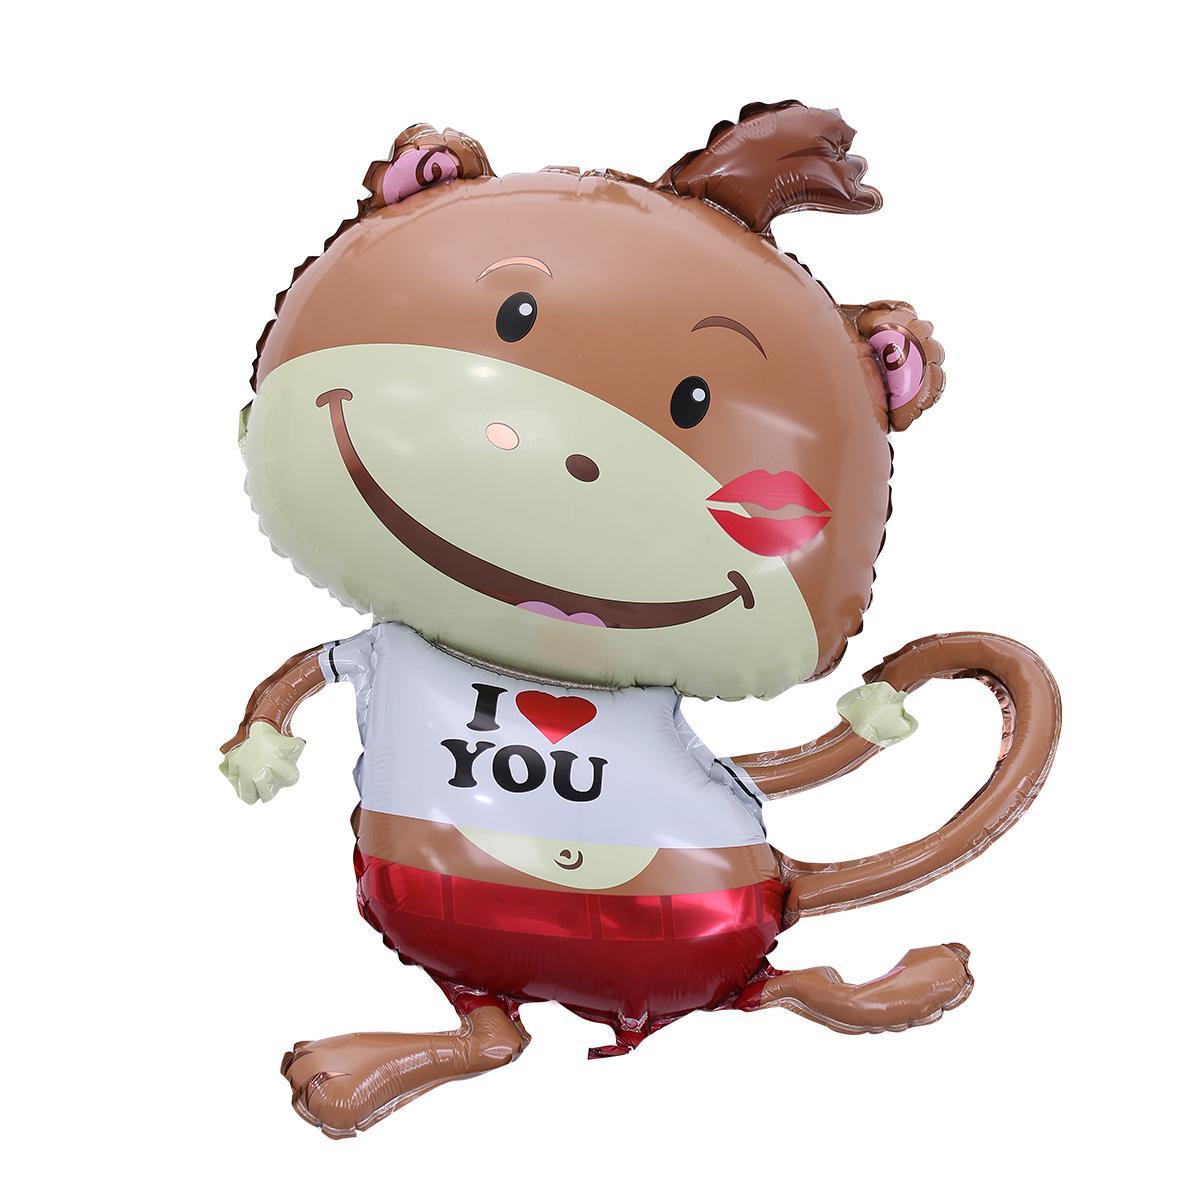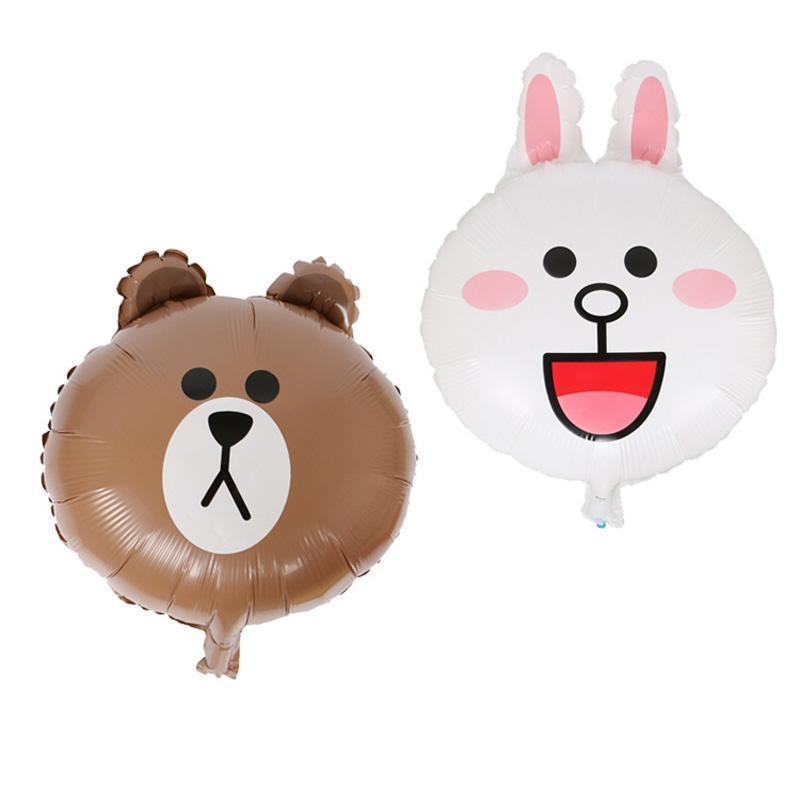The first image is the image on the left, the second image is the image on the right. Analyze the images presented: Is the assertion "One of the balloons is a dog that is wearing a collar and standing on four folded paper legs." valid? Answer yes or no. No. 